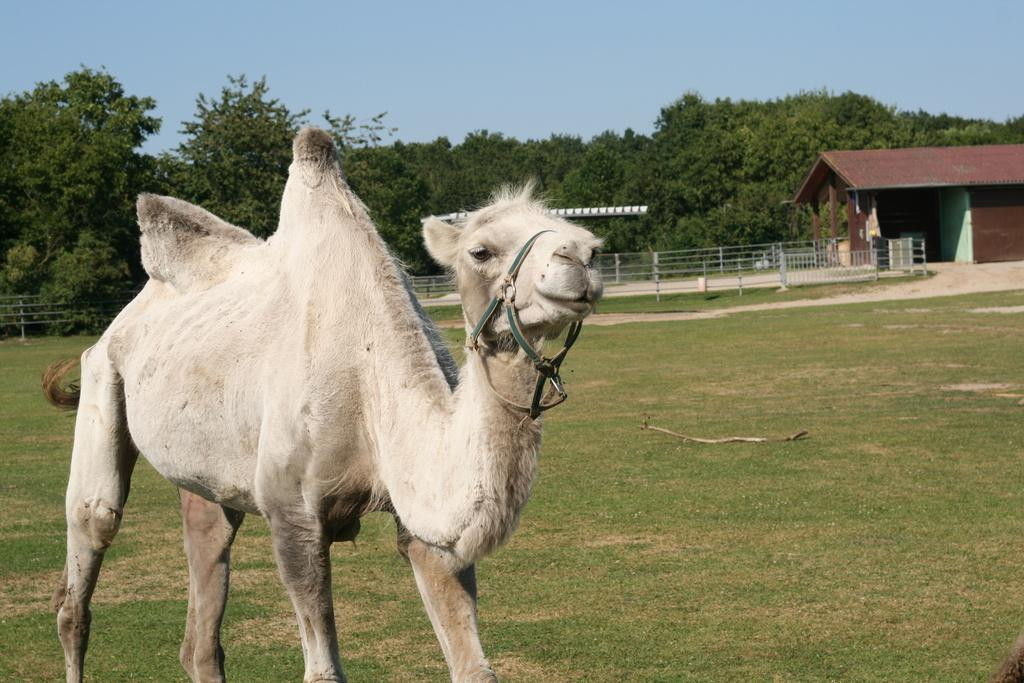What animal is present in the image? There is a camel in the image. What type of vegetation can be seen on the ground in the image? There is grass on the ground in the image. What can be seen in the back of the image? There are railings in the back of the image. What structure is located on the right side of the image? There is a building on the right side of the image. What is visible in the background of the image? There are trees and the sky visible in the background of the image. Where is the shelf located in the image? There is no shelf present in the image. What type of cream is being used by the camel in the image? There is no cream being used by the camel in the image. 